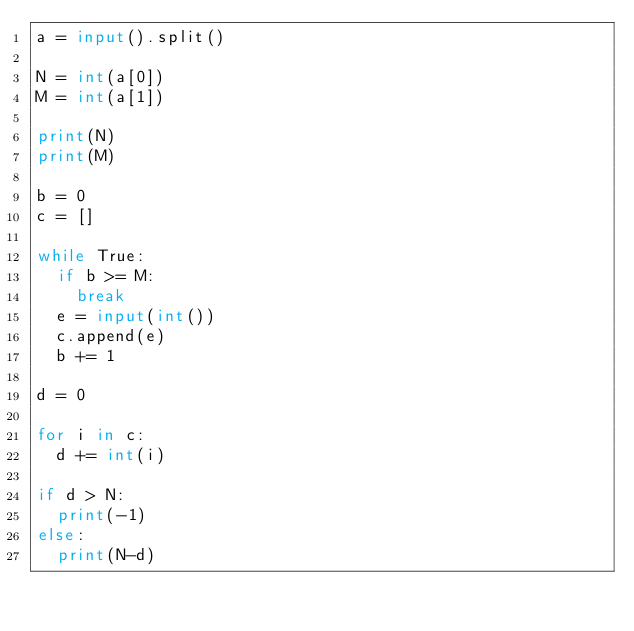<code> <loc_0><loc_0><loc_500><loc_500><_Python_>a = input().split()

N = int(a[0])
M = int(a[1])

print(N)
print(M)

b = 0
c = []

while True:
  if b >= M:
  	break
  e = input(int())
  c.append(e)
  b += 1

d = 0
  
for i in c:
  d += int(i)

if d > N:
  print(-1)
else:
  print(N-d)</code> 